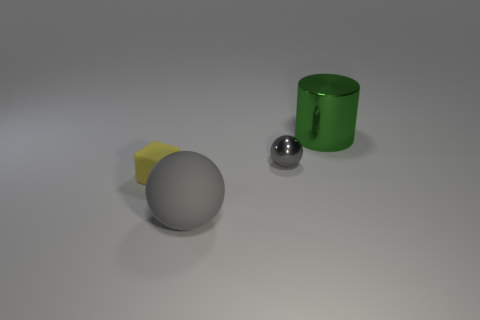Add 4 large green metal cylinders. How many objects exist? 8 Subtract all cylinders. How many objects are left? 3 Add 2 big green metal objects. How many big green metal objects are left? 3 Add 3 small gray blocks. How many small gray blocks exist? 3 Subtract 1 yellow blocks. How many objects are left? 3 Subtract all gray metal balls. Subtract all gray objects. How many objects are left? 1 